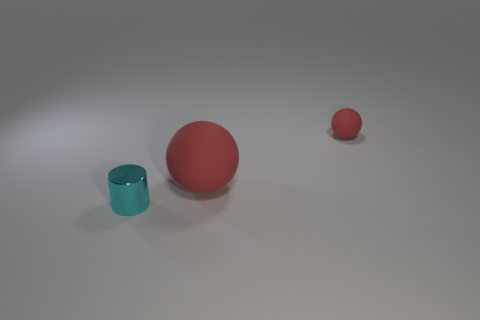What number of things are either tiny blue matte objects or objects left of the small red matte thing?
Offer a very short reply. 2. What is the size of the object that is the same material as the large sphere?
Your answer should be very brief. Small. There is a shiny object that is to the left of the tiny thing to the right of the tiny cyan metallic object; what is its shape?
Your response must be concise. Cylinder. How many green things are either metallic cylinders or big objects?
Provide a succinct answer. 0. There is a rubber sphere that is in front of the small object right of the shiny cylinder; are there any tiny matte balls that are left of it?
Give a very brief answer. No. The object that is the same color as the small matte ball is what shape?
Offer a terse response. Sphere. Are there any other things that are made of the same material as the big red ball?
Offer a very short reply. Yes. What number of big objects are cylinders or red objects?
Offer a terse response. 1. Does the tiny object behind the tiny metal cylinder have the same shape as the large red object?
Your answer should be very brief. Yes. Are there fewer tiny cyan objects than large cyan metallic things?
Your response must be concise. No. 